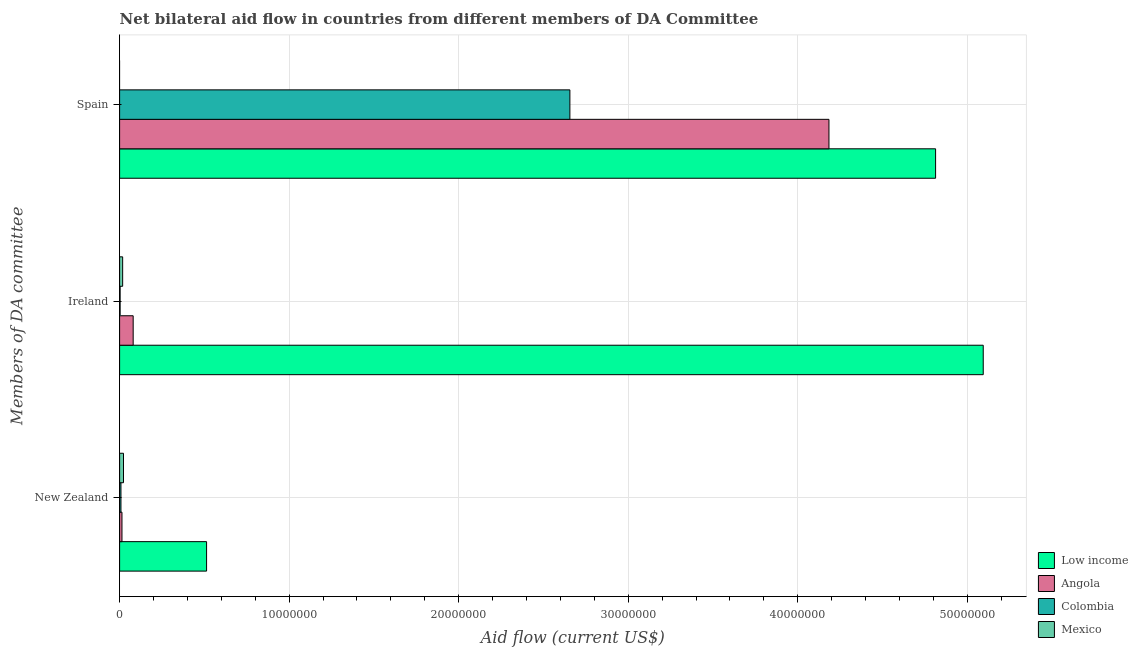How many groups of bars are there?
Offer a very short reply. 3. Are the number of bars per tick equal to the number of legend labels?
Offer a terse response. No. How many bars are there on the 1st tick from the top?
Ensure brevity in your answer.  3. How many bars are there on the 3rd tick from the bottom?
Keep it short and to the point. 3. What is the label of the 1st group of bars from the top?
Provide a succinct answer. Spain. What is the amount of aid provided by spain in Angola?
Offer a terse response. 4.18e+07. Across all countries, what is the maximum amount of aid provided by ireland?
Offer a terse response. 5.09e+07. Across all countries, what is the minimum amount of aid provided by new zealand?
Your response must be concise. 8.00e+04. What is the total amount of aid provided by ireland in the graph?
Keep it short and to the point. 5.20e+07. What is the difference between the amount of aid provided by new zealand in Low income and that in Colombia?
Provide a short and direct response. 5.05e+06. What is the difference between the amount of aid provided by new zealand in Low income and the amount of aid provided by spain in Angola?
Provide a succinct answer. -3.67e+07. What is the average amount of aid provided by ireland per country?
Provide a short and direct response. 1.30e+07. What is the difference between the amount of aid provided by new zealand and amount of aid provided by ireland in Mexico?
Offer a very short reply. 5.00e+04. What is the ratio of the amount of aid provided by ireland in Low income to that in Colombia?
Make the answer very short. 1698. Is the amount of aid provided by ireland in Mexico less than that in Angola?
Offer a very short reply. Yes. What is the difference between the highest and the second highest amount of aid provided by ireland?
Your answer should be compact. 5.01e+07. What is the difference between the highest and the lowest amount of aid provided by spain?
Offer a very short reply. 4.81e+07. How many bars are there?
Keep it short and to the point. 11. Are all the bars in the graph horizontal?
Provide a succinct answer. Yes. What is the difference between two consecutive major ticks on the X-axis?
Make the answer very short. 1.00e+07. How many legend labels are there?
Your response must be concise. 4. How are the legend labels stacked?
Ensure brevity in your answer.  Vertical. What is the title of the graph?
Your response must be concise. Net bilateral aid flow in countries from different members of DA Committee. What is the label or title of the X-axis?
Offer a very short reply. Aid flow (current US$). What is the label or title of the Y-axis?
Give a very brief answer. Members of DA committee. What is the Aid flow (current US$) in Low income in New Zealand?
Offer a very short reply. 5.13e+06. What is the Aid flow (current US$) in Colombia in New Zealand?
Your answer should be compact. 8.00e+04. What is the Aid flow (current US$) of Mexico in New Zealand?
Provide a succinct answer. 2.30e+05. What is the Aid flow (current US$) of Low income in Ireland?
Provide a succinct answer. 5.09e+07. What is the Aid flow (current US$) of Colombia in Ireland?
Keep it short and to the point. 3.00e+04. What is the Aid flow (current US$) in Mexico in Ireland?
Offer a very short reply. 1.80e+05. What is the Aid flow (current US$) in Low income in Spain?
Your answer should be compact. 4.81e+07. What is the Aid flow (current US$) of Angola in Spain?
Provide a short and direct response. 4.18e+07. What is the Aid flow (current US$) in Colombia in Spain?
Provide a short and direct response. 2.66e+07. Across all Members of DA committee, what is the maximum Aid flow (current US$) in Low income?
Your answer should be compact. 5.09e+07. Across all Members of DA committee, what is the maximum Aid flow (current US$) of Angola?
Provide a succinct answer. 4.18e+07. Across all Members of DA committee, what is the maximum Aid flow (current US$) of Colombia?
Offer a very short reply. 2.66e+07. Across all Members of DA committee, what is the minimum Aid flow (current US$) of Low income?
Give a very brief answer. 5.13e+06. Across all Members of DA committee, what is the minimum Aid flow (current US$) in Angola?
Offer a very short reply. 1.40e+05. Across all Members of DA committee, what is the minimum Aid flow (current US$) of Colombia?
Your answer should be very brief. 3.00e+04. What is the total Aid flow (current US$) in Low income in the graph?
Your response must be concise. 1.04e+08. What is the total Aid flow (current US$) of Angola in the graph?
Give a very brief answer. 4.28e+07. What is the total Aid flow (current US$) of Colombia in the graph?
Provide a succinct answer. 2.67e+07. What is the difference between the Aid flow (current US$) of Low income in New Zealand and that in Ireland?
Make the answer very short. -4.58e+07. What is the difference between the Aid flow (current US$) in Angola in New Zealand and that in Ireland?
Offer a very short reply. -6.60e+05. What is the difference between the Aid flow (current US$) in Low income in New Zealand and that in Spain?
Your response must be concise. -4.30e+07. What is the difference between the Aid flow (current US$) of Angola in New Zealand and that in Spain?
Your answer should be compact. -4.17e+07. What is the difference between the Aid flow (current US$) of Colombia in New Zealand and that in Spain?
Provide a short and direct response. -2.65e+07. What is the difference between the Aid flow (current US$) of Low income in Ireland and that in Spain?
Offer a very short reply. 2.81e+06. What is the difference between the Aid flow (current US$) of Angola in Ireland and that in Spain?
Offer a terse response. -4.10e+07. What is the difference between the Aid flow (current US$) in Colombia in Ireland and that in Spain?
Offer a terse response. -2.65e+07. What is the difference between the Aid flow (current US$) of Low income in New Zealand and the Aid flow (current US$) of Angola in Ireland?
Provide a succinct answer. 4.33e+06. What is the difference between the Aid flow (current US$) in Low income in New Zealand and the Aid flow (current US$) in Colombia in Ireland?
Your answer should be compact. 5.10e+06. What is the difference between the Aid flow (current US$) in Low income in New Zealand and the Aid flow (current US$) in Mexico in Ireland?
Provide a succinct answer. 4.95e+06. What is the difference between the Aid flow (current US$) in Angola in New Zealand and the Aid flow (current US$) in Mexico in Ireland?
Give a very brief answer. -4.00e+04. What is the difference between the Aid flow (current US$) of Colombia in New Zealand and the Aid flow (current US$) of Mexico in Ireland?
Provide a short and direct response. -1.00e+05. What is the difference between the Aid flow (current US$) of Low income in New Zealand and the Aid flow (current US$) of Angola in Spain?
Your answer should be compact. -3.67e+07. What is the difference between the Aid flow (current US$) of Low income in New Zealand and the Aid flow (current US$) of Colombia in Spain?
Offer a terse response. -2.14e+07. What is the difference between the Aid flow (current US$) in Angola in New Zealand and the Aid flow (current US$) in Colombia in Spain?
Your response must be concise. -2.64e+07. What is the difference between the Aid flow (current US$) in Low income in Ireland and the Aid flow (current US$) in Angola in Spain?
Give a very brief answer. 9.10e+06. What is the difference between the Aid flow (current US$) in Low income in Ireland and the Aid flow (current US$) in Colombia in Spain?
Give a very brief answer. 2.44e+07. What is the difference between the Aid flow (current US$) of Angola in Ireland and the Aid flow (current US$) of Colombia in Spain?
Offer a very short reply. -2.58e+07. What is the average Aid flow (current US$) of Low income per Members of DA committee?
Keep it short and to the point. 3.47e+07. What is the average Aid flow (current US$) in Angola per Members of DA committee?
Provide a short and direct response. 1.43e+07. What is the average Aid flow (current US$) in Colombia per Members of DA committee?
Your answer should be very brief. 8.89e+06. What is the average Aid flow (current US$) of Mexico per Members of DA committee?
Provide a succinct answer. 1.37e+05. What is the difference between the Aid flow (current US$) of Low income and Aid flow (current US$) of Angola in New Zealand?
Your answer should be very brief. 4.99e+06. What is the difference between the Aid flow (current US$) in Low income and Aid flow (current US$) in Colombia in New Zealand?
Offer a terse response. 5.05e+06. What is the difference between the Aid flow (current US$) in Low income and Aid flow (current US$) in Mexico in New Zealand?
Give a very brief answer. 4.90e+06. What is the difference between the Aid flow (current US$) in Colombia and Aid flow (current US$) in Mexico in New Zealand?
Offer a very short reply. -1.50e+05. What is the difference between the Aid flow (current US$) in Low income and Aid flow (current US$) in Angola in Ireland?
Your answer should be compact. 5.01e+07. What is the difference between the Aid flow (current US$) of Low income and Aid flow (current US$) of Colombia in Ireland?
Provide a succinct answer. 5.09e+07. What is the difference between the Aid flow (current US$) in Low income and Aid flow (current US$) in Mexico in Ireland?
Provide a succinct answer. 5.08e+07. What is the difference between the Aid flow (current US$) in Angola and Aid flow (current US$) in Colombia in Ireland?
Offer a terse response. 7.70e+05. What is the difference between the Aid flow (current US$) of Angola and Aid flow (current US$) of Mexico in Ireland?
Your response must be concise. 6.20e+05. What is the difference between the Aid flow (current US$) in Colombia and Aid flow (current US$) in Mexico in Ireland?
Your response must be concise. -1.50e+05. What is the difference between the Aid flow (current US$) of Low income and Aid flow (current US$) of Angola in Spain?
Give a very brief answer. 6.29e+06. What is the difference between the Aid flow (current US$) in Low income and Aid flow (current US$) in Colombia in Spain?
Ensure brevity in your answer.  2.16e+07. What is the difference between the Aid flow (current US$) of Angola and Aid flow (current US$) of Colombia in Spain?
Offer a terse response. 1.53e+07. What is the ratio of the Aid flow (current US$) of Low income in New Zealand to that in Ireland?
Your response must be concise. 0.1. What is the ratio of the Aid flow (current US$) in Angola in New Zealand to that in Ireland?
Offer a very short reply. 0.17. What is the ratio of the Aid flow (current US$) in Colombia in New Zealand to that in Ireland?
Give a very brief answer. 2.67. What is the ratio of the Aid flow (current US$) of Mexico in New Zealand to that in Ireland?
Make the answer very short. 1.28. What is the ratio of the Aid flow (current US$) in Low income in New Zealand to that in Spain?
Ensure brevity in your answer.  0.11. What is the ratio of the Aid flow (current US$) in Angola in New Zealand to that in Spain?
Your answer should be very brief. 0. What is the ratio of the Aid flow (current US$) in Colombia in New Zealand to that in Spain?
Provide a short and direct response. 0. What is the ratio of the Aid flow (current US$) in Low income in Ireland to that in Spain?
Make the answer very short. 1.06. What is the ratio of the Aid flow (current US$) of Angola in Ireland to that in Spain?
Your answer should be compact. 0.02. What is the ratio of the Aid flow (current US$) of Colombia in Ireland to that in Spain?
Give a very brief answer. 0. What is the difference between the highest and the second highest Aid flow (current US$) of Low income?
Your response must be concise. 2.81e+06. What is the difference between the highest and the second highest Aid flow (current US$) of Angola?
Offer a terse response. 4.10e+07. What is the difference between the highest and the second highest Aid flow (current US$) in Colombia?
Your answer should be compact. 2.65e+07. What is the difference between the highest and the lowest Aid flow (current US$) in Low income?
Your answer should be very brief. 4.58e+07. What is the difference between the highest and the lowest Aid flow (current US$) of Angola?
Give a very brief answer. 4.17e+07. What is the difference between the highest and the lowest Aid flow (current US$) of Colombia?
Keep it short and to the point. 2.65e+07. What is the difference between the highest and the lowest Aid flow (current US$) of Mexico?
Give a very brief answer. 2.30e+05. 